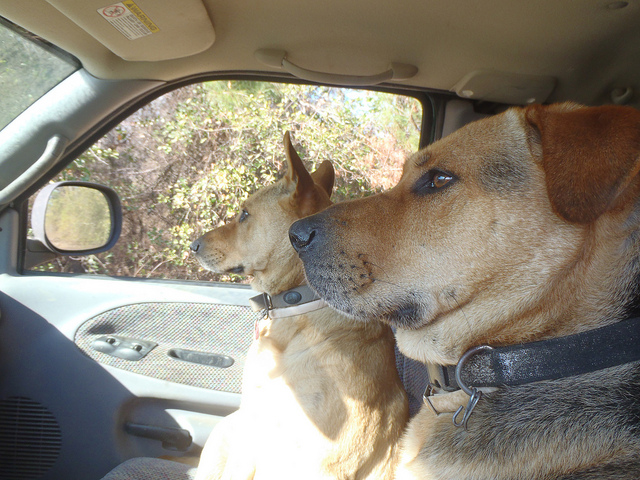How many dogs are in this scene? There are two dogs in the scene, both attentively looking out of the car window, perhaps watching for something interesting outside or waiting for their owner. 